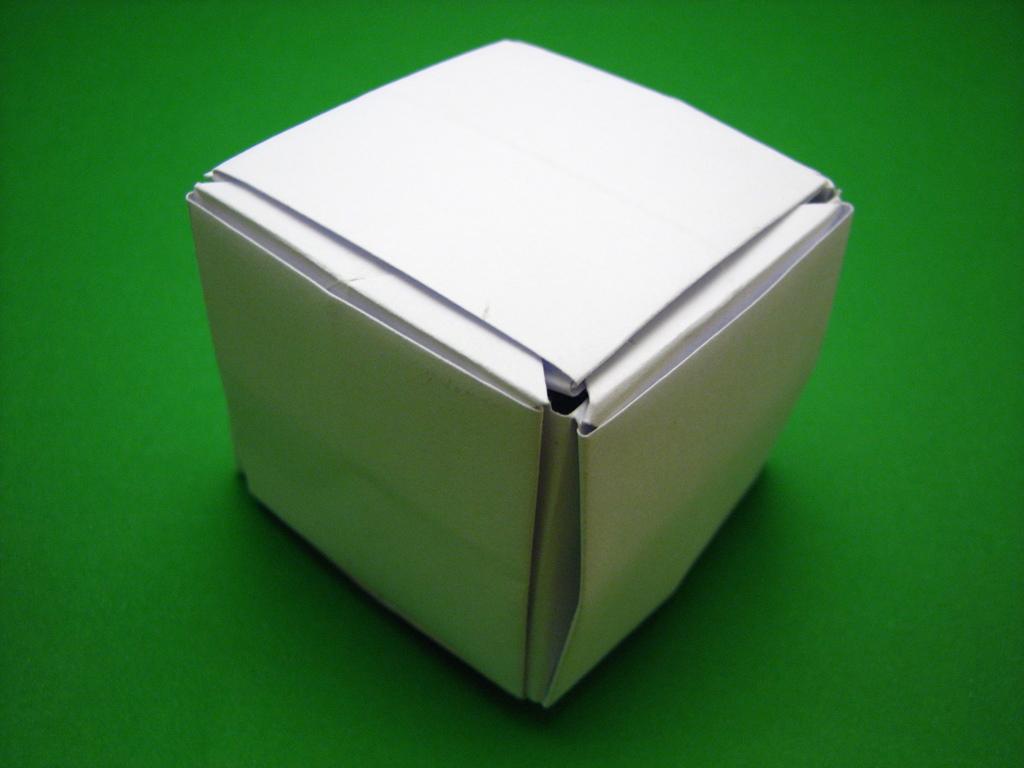In one or two sentences, can you explain what this image depicts? In the picture I can see a white color box on a green color surface. 